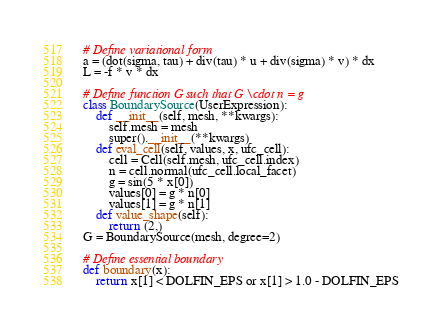<code> <loc_0><loc_0><loc_500><loc_500><_Python_># Define variational form
a = (dot(sigma, tau) + div(tau) * u + div(sigma) * v) * dx
L = -f * v * dx

# Define function G such that G \cdot n = g
class BoundarySource(UserExpression):
    def __init__(self, mesh, **kwargs):
        self.mesh = mesh
        super().__init__(**kwargs)
    def eval_cell(self, values, x, ufc_cell):
        cell = Cell(self.mesh, ufc_cell.index)
        n = cell.normal(ufc_cell.local_facet)
        g = sin(5 * x[0])
        values[0] = g * n[0]
        values[1] = g * n[1]
    def value_shape(self):
        return (2,)
G = BoundarySource(mesh, degree=2)

# Define essential boundary
def boundary(x):
    return x[1] < DOLFIN_EPS or x[1] > 1.0 - DOLFIN_EPS</code> 